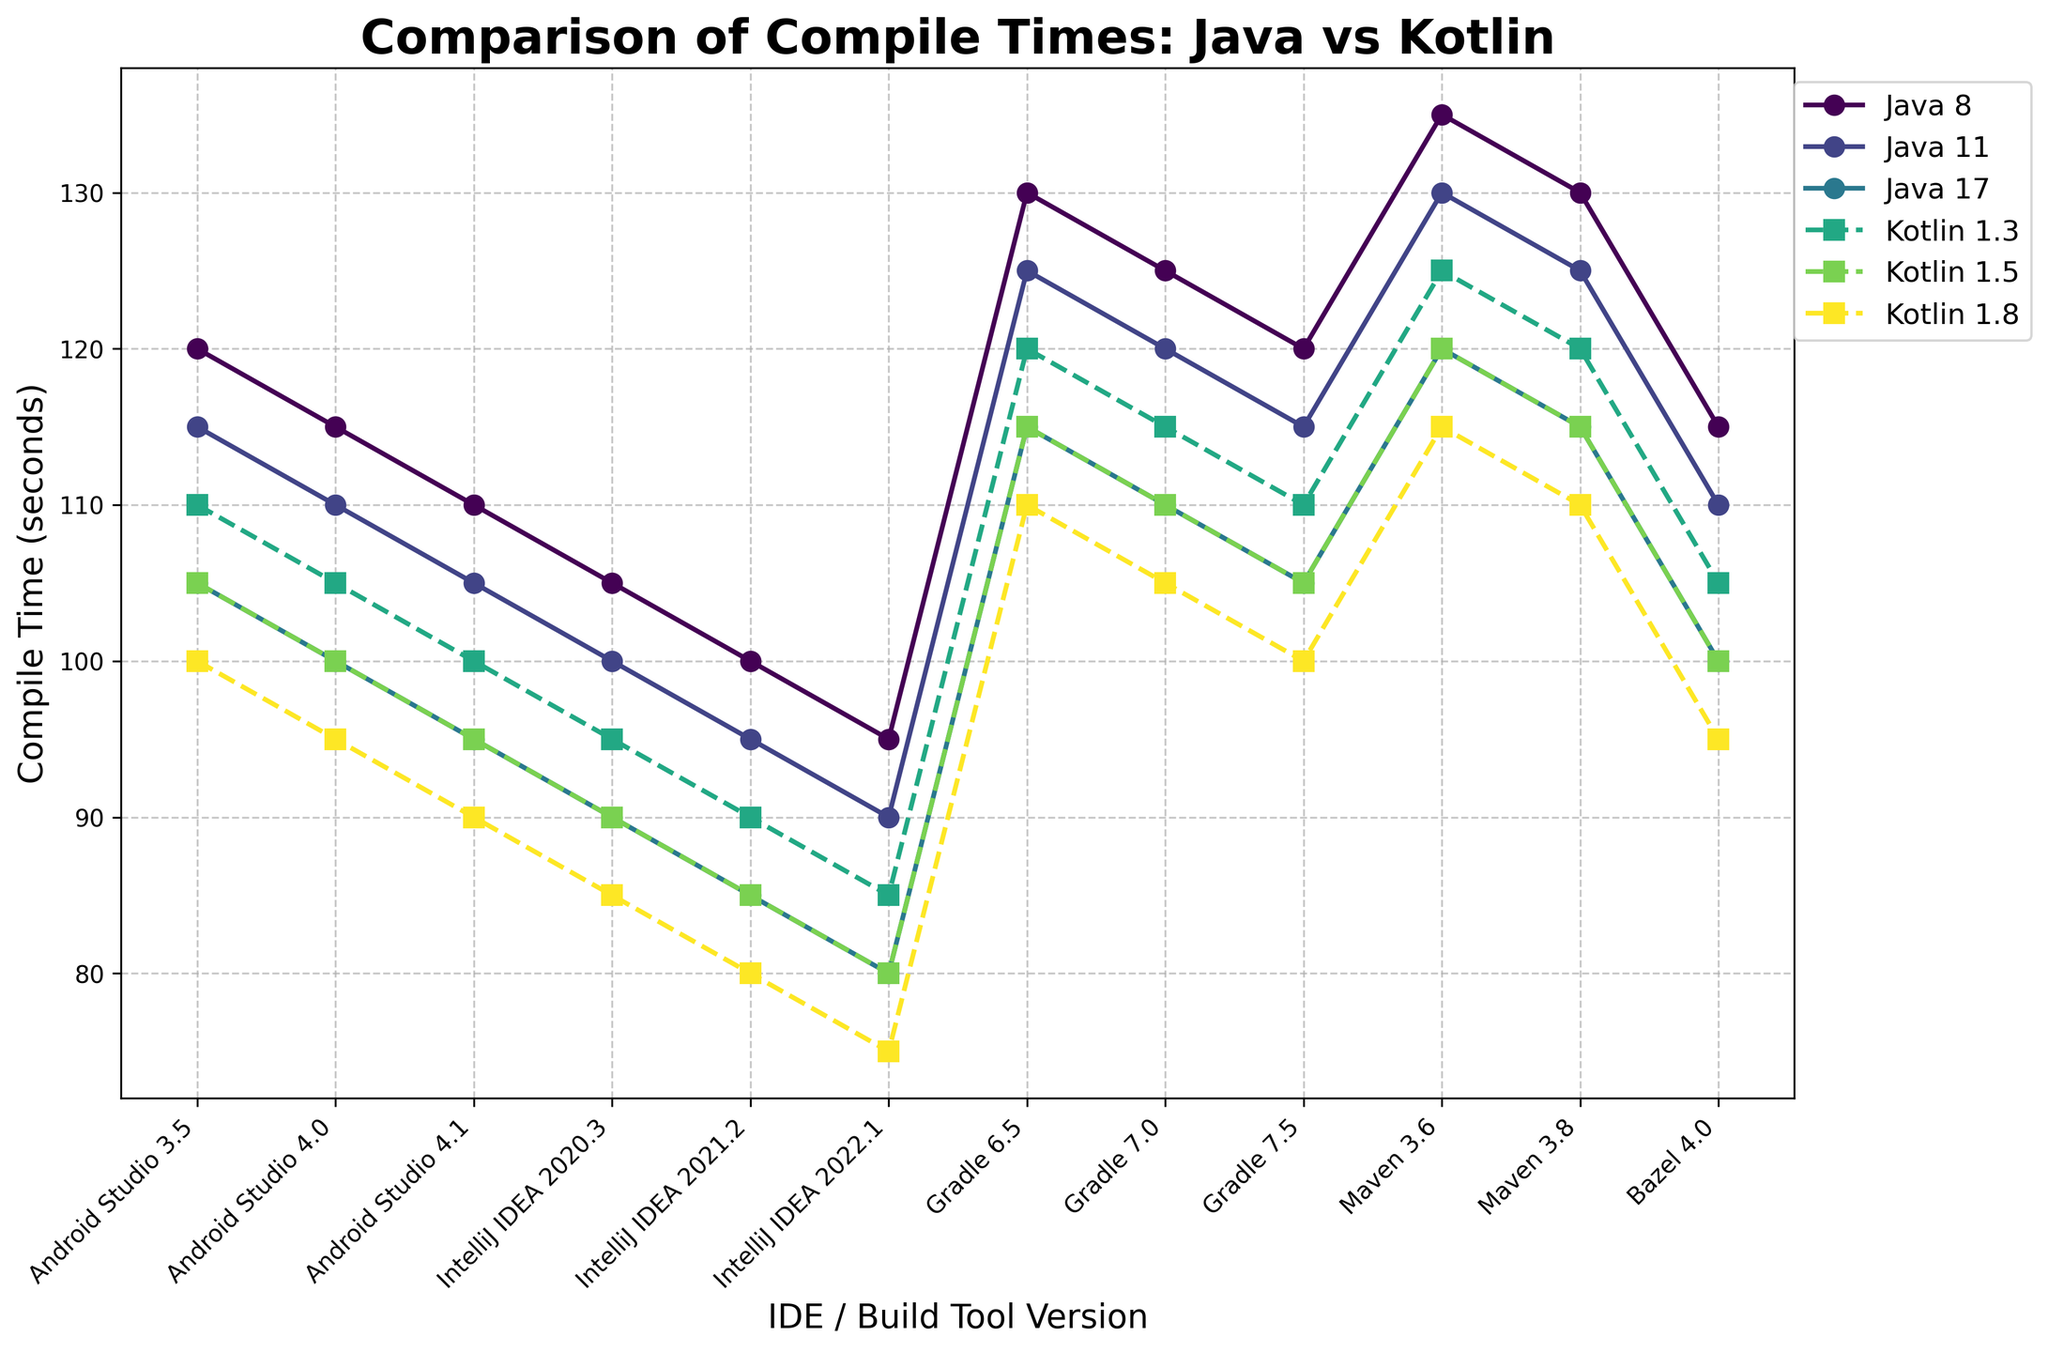What is the trend in compile times for Java 11 from Android Studio 3.5 to IntelliJ IDEA 2022.1? To see the trend in compile times for Java 11, look at the data points for Java 11 across the versions. Notice how the compile time decreases. Specifically, Java 11 has compile times of 115, 110, 105, 100, 95, and 90 seconds across the different versions of Android Studio and IntelliJ IDEA, showing a consistent decline.
Answer: Decreasing Which Kotlin version has the smallest compile time in IntelliJ IDEA 2022.1? To identify the smallest compile time for Kotlin in IntelliJ IDEA 2022.1, compare the compile times for Kotlin 1.3, 1.5, and 1.8. They are 85, 80, and 75 seconds, respectively. Hence, Kotlin 1.8 has the smallest compile time.
Answer: Kotlin 1.8 Compare the compile times of Java 8 and Kotlin 1.3 in Android Studio 3.5. Which one is faster and by how much? For Android Studio 3.5, the compile times for Java 8 and Kotlin 1.3 are 120 seconds and 110 seconds respectively. To find which one is faster and by how much, subtract the smaller time from the larger time: 120 - 110 = 10 seconds. Thus, Kotlin 1.3 is faster by 10 seconds.
Answer: Kotlin 1.3 by 10 seconds What is the average compile time for Java 17 across all listed versions? To find the average compile time for Java 17, add the compile times across all versions and divide by the number of versions. The compile times are 105, 100, 95, 90, 85, 80, 115, 110, 105, 120, 115, 100. Sum these values to get 1210, then divide by 12. Therefore, the average compile time is 1210/12 which equals approximately 100.8 seconds.
Answer: Approximately 100.8 seconds Does the compile time for Kotlin 1.5 decrease or increase from Gradle 6.5 to Gradle 7.5? To determine this, look at the compile times for Kotlin 1.5 in Gradle 6.5, 7.0, and 7.5 which are 115, 110, and 105 seconds, respectively. The compile time decreases from 115 to 105 seconds.
Answer: Decreases How much faster is Kotlin 1.8 compared to Java 8 in IntelliJ IDEA 2021.2? For IntelliJ IDEA 2021.2, the compile times for Kotlin 1.8 and Java 8 are 80 seconds and 100 seconds, respectively. The difference is 100 - 80 = 20 seconds, so Kotlin 1.8 is faster by 20 seconds.
Answer: 20 seconds What is the consistent behavior observed across versions for Kotlin compile times compared to Java? Observing the plot, Kotlin compile times are consistently lower compared to Java compile times across the same version of Android Studio, IntelliJ IDEA, Gradle, Maven, and Bazel. The lines representing Kotlin are consistently below those for Java across different versions.
Answer: Kotlin is consistently faster Identify the IDE or build tool where Kotlin 1.3 shows the least compile time improvement compared to Java 17. Calculate the difference between Kotlin 1.3 and Java 17 compile times across the variants: 
- Android Studio 3.5: Java 17 is 105, Kotlin 1.3 is 110, difference is -5 seconds (indicating Java 17 is faster)
- Android Studio 4.0: Java 17 is 100, Kotlin 1.3 is 105, difference is -5 
- Android Studio 4.1: Java 17 is 95, Kotlin 1.3 is 100, difference is -5 
- IntelliJ IDEA 2020.3: Java 17 is 90, Kotlin 1.3 is 95, difference is -5 
- IntelliJ IDEA 2021.2: Java 17 is 85, Kotlin 1.3 is 90, difference is -5 
- IntelliJ IDEA 2022.1: Java 17 is 80, Kotlin 1.3 is 85, difference is -5 
- Gradle 6.5: Java 17 is 115, Kotlin 1.3 is 120, difference is -5 
- Gradle 7.0: Java 17 is 110, Kotlin 1.3 is 115, difference is -5 
- Gradle 7.5: Java 17 is 105, Kotlin 1.3 is 110, difference is -5 
- Maven 3.6: Java 17 is 120, Kotlin 1.3 is 125, difference is -5 
- Maven 3.8: Java 17 is 115, Kotlin 1.3 is 120, difference is -5 
- Bazel 4.0: Java 17 is 100, Kotlin 1.3 is 105, difference is -5
The least improvement (-5) is consistent across all.
Answer: Consistently -5 seconds across all 